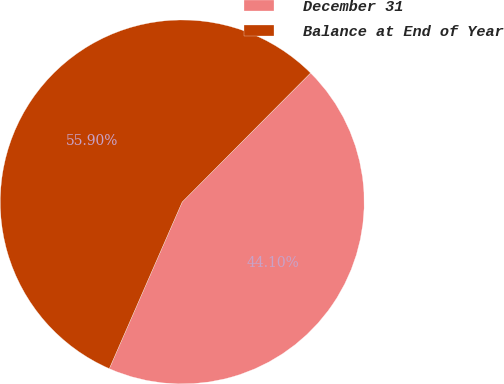Convert chart. <chart><loc_0><loc_0><loc_500><loc_500><pie_chart><fcel>December 31<fcel>Balance at End of Year<nl><fcel>44.1%<fcel>55.9%<nl></chart> 